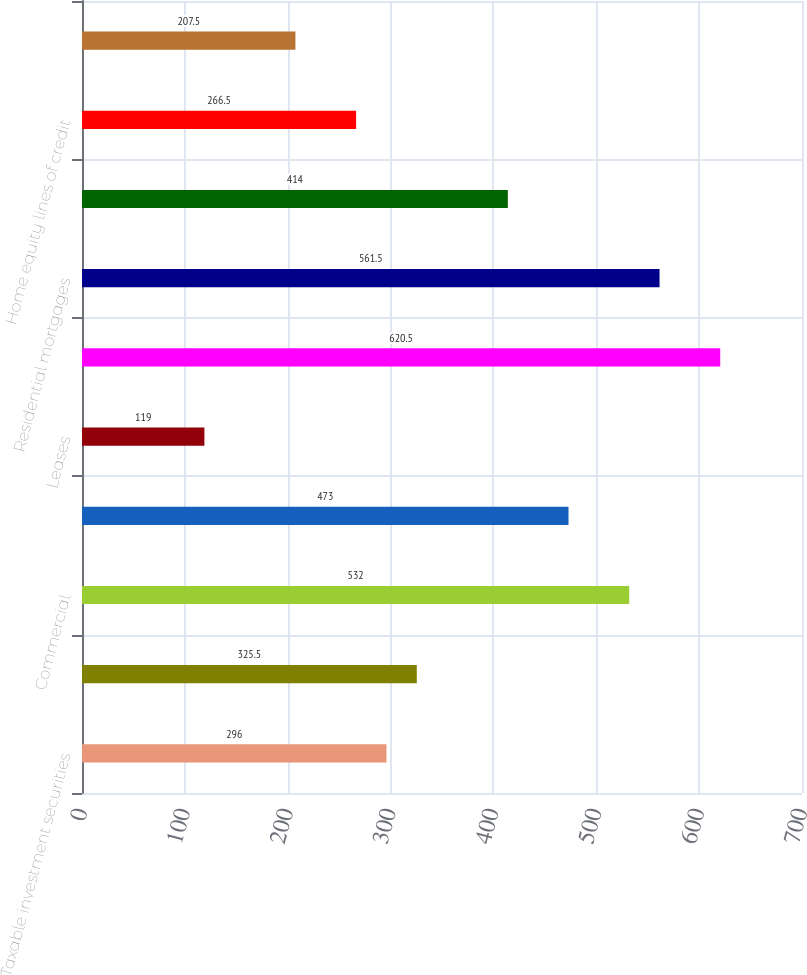<chart> <loc_0><loc_0><loc_500><loc_500><bar_chart><fcel>Taxable investment securities<fcel>Total investment securities<fcel>Commercial<fcel>Commercial real estate<fcel>Leases<fcel>Total commercial loans and<fcel>Residential mortgages<fcel>Home equity loans<fcel>Home equity lines of credit<fcel>Automobile<nl><fcel>296<fcel>325.5<fcel>532<fcel>473<fcel>119<fcel>620.5<fcel>561.5<fcel>414<fcel>266.5<fcel>207.5<nl></chart> 